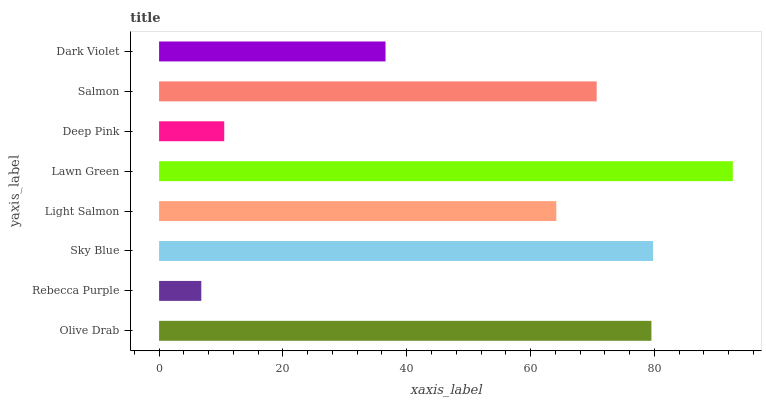Is Rebecca Purple the minimum?
Answer yes or no. Yes. Is Lawn Green the maximum?
Answer yes or no. Yes. Is Sky Blue the minimum?
Answer yes or no. No. Is Sky Blue the maximum?
Answer yes or no. No. Is Sky Blue greater than Rebecca Purple?
Answer yes or no. Yes. Is Rebecca Purple less than Sky Blue?
Answer yes or no. Yes. Is Rebecca Purple greater than Sky Blue?
Answer yes or no. No. Is Sky Blue less than Rebecca Purple?
Answer yes or no. No. Is Salmon the high median?
Answer yes or no. Yes. Is Light Salmon the low median?
Answer yes or no. Yes. Is Deep Pink the high median?
Answer yes or no. No. Is Rebecca Purple the low median?
Answer yes or no. No. 